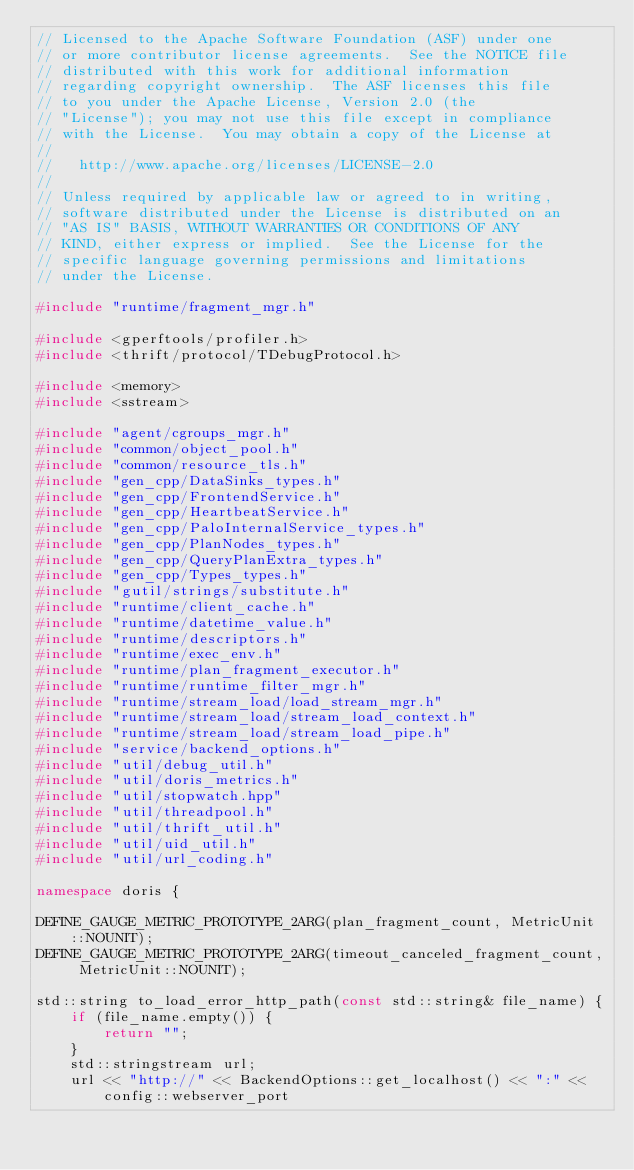<code> <loc_0><loc_0><loc_500><loc_500><_C++_>// Licensed to the Apache Software Foundation (ASF) under one
// or more contributor license agreements.  See the NOTICE file
// distributed with this work for additional information
// regarding copyright ownership.  The ASF licenses this file
// to you under the Apache License, Version 2.0 (the
// "License"); you may not use this file except in compliance
// with the License.  You may obtain a copy of the License at
//
//   http://www.apache.org/licenses/LICENSE-2.0
//
// Unless required by applicable law or agreed to in writing,
// software distributed under the License is distributed on an
// "AS IS" BASIS, WITHOUT WARRANTIES OR CONDITIONS OF ANY
// KIND, either express or implied.  See the License for the
// specific language governing permissions and limitations
// under the License.

#include "runtime/fragment_mgr.h"

#include <gperftools/profiler.h>
#include <thrift/protocol/TDebugProtocol.h>

#include <memory>
#include <sstream>

#include "agent/cgroups_mgr.h"
#include "common/object_pool.h"
#include "common/resource_tls.h"
#include "gen_cpp/DataSinks_types.h"
#include "gen_cpp/FrontendService.h"
#include "gen_cpp/HeartbeatService.h"
#include "gen_cpp/PaloInternalService_types.h"
#include "gen_cpp/PlanNodes_types.h"
#include "gen_cpp/QueryPlanExtra_types.h"
#include "gen_cpp/Types_types.h"
#include "gutil/strings/substitute.h"
#include "runtime/client_cache.h"
#include "runtime/datetime_value.h"
#include "runtime/descriptors.h"
#include "runtime/exec_env.h"
#include "runtime/plan_fragment_executor.h"
#include "runtime/runtime_filter_mgr.h"
#include "runtime/stream_load/load_stream_mgr.h"
#include "runtime/stream_load/stream_load_context.h"
#include "runtime/stream_load/stream_load_pipe.h"
#include "service/backend_options.h"
#include "util/debug_util.h"
#include "util/doris_metrics.h"
#include "util/stopwatch.hpp"
#include "util/threadpool.h"
#include "util/thrift_util.h"
#include "util/uid_util.h"
#include "util/url_coding.h"

namespace doris {

DEFINE_GAUGE_METRIC_PROTOTYPE_2ARG(plan_fragment_count, MetricUnit::NOUNIT);
DEFINE_GAUGE_METRIC_PROTOTYPE_2ARG(timeout_canceled_fragment_count, MetricUnit::NOUNIT);

std::string to_load_error_http_path(const std::string& file_name) {
    if (file_name.empty()) {
        return "";
    }
    std::stringstream url;
    url << "http://" << BackendOptions::get_localhost() << ":" << config::webserver_port</code> 